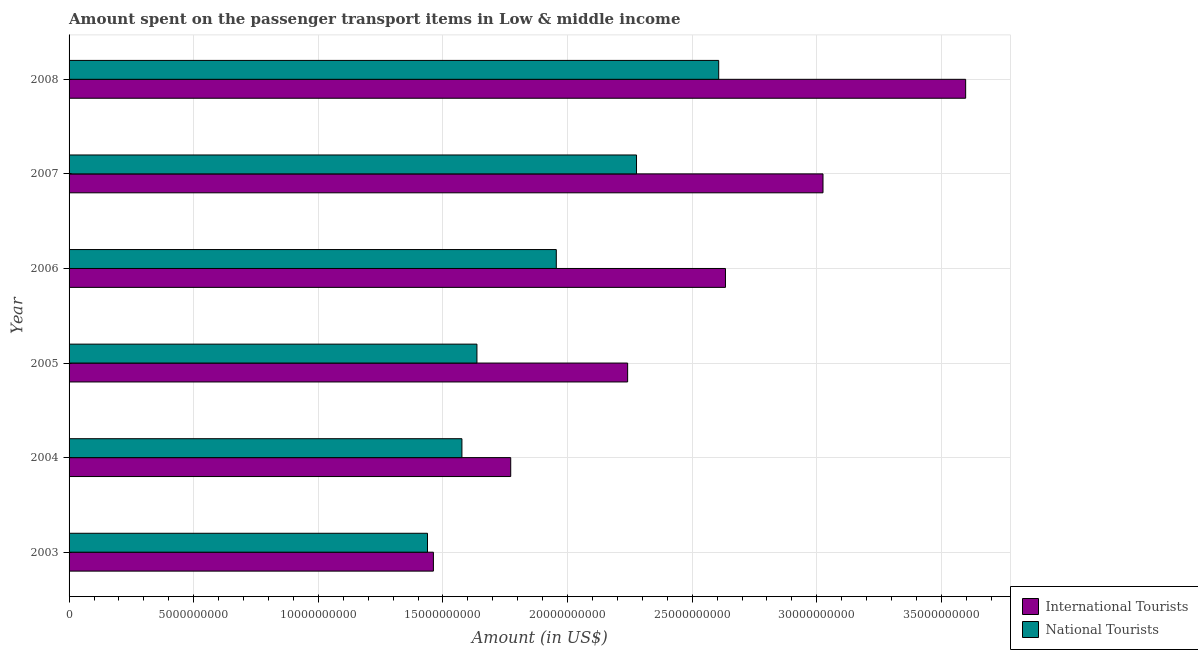How many different coloured bars are there?
Provide a succinct answer. 2. How many groups of bars are there?
Your answer should be compact. 6. Are the number of bars per tick equal to the number of legend labels?
Give a very brief answer. Yes. How many bars are there on the 3rd tick from the top?
Keep it short and to the point. 2. How many bars are there on the 2nd tick from the bottom?
Provide a succinct answer. 2. What is the label of the 5th group of bars from the top?
Offer a terse response. 2004. What is the amount spent on transport items of national tourists in 2008?
Your response must be concise. 2.61e+1. Across all years, what is the maximum amount spent on transport items of national tourists?
Keep it short and to the point. 2.61e+1. Across all years, what is the minimum amount spent on transport items of international tourists?
Offer a very short reply. 1.46e+1. What is the total amount spent on transport items of international tourists in the graph?
Make the answer very short. 1.47e+11. What is the difference between the amount spent on transport items of national tourists in 2005 and that in 2006?
Your answer should be very brief. -3.18e+09. What is the difference between the amount spent on transport items of national tourists in 2005 and the amount spent on transport items of international tourists in 2006?
Ensure brevity in your answer.  -9.97e+09. What is the average amount spent on transport items of international tourists per year?
Give a very brief answer. 2.46e+1. In the year 2004, what is the difference between the amount spent on transport items of international tourists and amount spent on transport items of national tourists?
Your response must be concise. 1.96e+09. What is the ratio of the amount spent on transport items of international tourists in 2004 to that in 2006?
Make the answer very short. 0.67. Is the difference between the amount spent on transport items of national tourists in 2003 and 2005 greater than the difference between the amount spent on transport items of international tourists in 2003 and 2005?
Provide a short and direct response. Yes. What is the difference between the highest and the second highest amount spent on transport items of national tourists?
Offer a terse response. 3.30e+09. What is the difference between the highest and the lowest amount spent on transport items of national tourists?
Your answer should be compact. 1.17e+1. Is the sum of the amount spent on transport items of national tourists in 2005 and 2006 greater than the maximum amount spent on transport items of international tourists across all years?
Offer a terse response. No. What does the 2nd bar from the top in 2008 represents?
Keep it short and to the point. International Tourists. What does the 2nd bar from the bottom in 2008 represents?
Give a very brief answer. National Tourists. How many bars are there?
Make the answer very short. 12. Are all the bars in the graph horizontal?
Keep it short and to the point. Yes. How many years are there in the graph?
Keep it short and to the point. 6. What is the difference between two consecutive major ticks on the X-axis?
Make the answer very short. 5.00e+09. What is the title of the graph?
Your answer should be compact. Amount spent on the passenger transport items in Low & middle income. What is the label or title of the X-axis?
Provide a succinct answer. Amount (in US$). What is the Amount (in US$) of International Tourists in 2003?
Make the answer very short. 1.46e+1. What is the Amount (in US$) of National Tourists in 2003?
Your response must be concise. 1.44e+1. What is the Amount (in US$) of International Tourists in 2004?
Ensure brevity in your answer.  1.77e+1. What is the Amount (in US$) in National Tourists in 2004?
Offer a very short reply. 1.58e+1. What is the Amount (in US$) in International Tourists in 2005?
Provide a short and direct response. 2.24e+1. What is the Amount (in US$) of National Tourists in 2005?
Offer a terse response. 1.64e+1. What is the Amount (in US$) in International Tourists in 2006?
Your response must be concise. 2.63e+1. What is the Amount (in US$) in National Tourists in 2006?
Make the answer very short. 1.95e+1. What is the Amount (in US$) in International Tourists in 2007?
Make the answer very short. 3.02e+1. What is the Amount (in US$) in National Tourists in 2007?
Offer a very short reply. 2.28e+1. What is the Amount (in US$) in International Tourists in 2008?
Give a very brief answer. 3.60e+1. What is the Amount (in US$) of National Tourists in 2008?
Offer a terse response. 2.61e+1. Across all years, what is the maximum Amount (in US$) of International Tourists?
Ensure brevity in your answer.  3.60e+1. Across all years, what is the maximum Amount (in US$) of National Tourists?
Make the answer very short. 2.61e+1. Across all years, what is the minimum Amount (in US$) in International Tourists?
Offer a very short reply. 1.46e+1. Across all years, what is the minimum Amount (in US$) of National Tourists?
Your response must be concise. 1.44e+1. What is the total Amount (in US$) of International Tourists in the graph?
Provide a succinct answer. 1.47e+11. What is the total Amount (in US$) of National Tourists in the graph?
Offer a terse response. 1.15e+11. What is the difference between the Amount (in US$) in International Tourists in 2003 and that in 2004?
Your answer should be compact. -3.10e+09. What is the difference between the Amount (in US$) of National Tourists in 2003 and that in 2004?
Provide a short and direct response. -1.38e+09. What is the difference between the Amount (in US$) in International Tourists in 2003 and that in 2005?
Ensure brevity in your answer.  -7.79e+09. What is the difference between the Amount (in US$) of National Tourists in 2003 and that in 2005?
Offer a terse response. -1.98e+09. What is the difference between the Amount (in US$) in International Tourists in 2003 and that in 2006?
Make the answer very short. -1.17e+1. What is the difference between the Amount (in US$) in National Tourists in 2003 and that in 2006?
Provide a short and direct response. -5.17e+09. What is the difference between the Amount (in US$) in International Tourists in 2003 and that in 2007?
Provide a succinct answer. -1.56e+1. What is the difference between the Amount (in US$) in National Tourists in 2003 and that in 2007?
Make the answer very short. -8.39e+09. What is the difference between the Amount (in US$) in International Tourists in 2003 and that in 2008?
Your answer should be very brief. -2.14e+1. What is the difference between the Amount (in US$) of National Tourists in 2003 and that in 2008?
Ensure brevity in your answer.  -1.17e+1. What is the difference between the Amount (in US$) in International Tourists in 2004 and that in 2005?
Make the answer very short. -4.69e+09. What is the difference between the Amount (in US$) in National Tourists in 2004 and that in 2005?
Your answer should be compact. -6.02e+08. What is the difference between the Amount (in US$) in International Tourists in 2004 and that in 2006?
Your answer should be compact. -8.62e+09. What is the difference between the Amount (in US$) in National Tourists in 2004 and that in 2006?
Offer a terse response. -3.79e+09. What is the difference between the Amount (in US$) in International Tourists in 2004 and that in 2007?
Provide a short and direct response. -1.25e+1. What is the difference between the Amount (in US$) of National Tourists in 2004 and that in 2007?
Make the answer very short. -7.00e+09. What is the difference between the Amount (in US$) of International Tourists in 2004 and that in 2008?
Your answer should be very brief. -1.83e+1. What is the difference between the Amount (in US$) in National Tourists in 2004 and that in 2008?
Your response must be concise. -1.03e+1. What is the difference between the Amount (in US$) of International Tourists in 2005 and that in 2006?
Offer a very short reply. -3.92e+09. What is the difference between the Amount (in US$) of National Tourists in 2005 and that in 2006?
Keep it short and to the point. -3.18e+09. What is the difference between the Amount (in US$) in International Tourists in 2005 and that in 2007?
Give a very brief answer. -7.84e+09. What is the difference between the Amount (in US$) of National Tourists in 2005 and that in 2007?
Make the answer very short. -6.40e+09. What is the difference between the Amount (in US$) in International Tourists in 2005 and that in 2008?
Provide a short and direct response. -1.36e+1. What is the difference between the Amount (in US$) in National Tourists in 2005 and that in 2008?
Provide a short and direct response. -9.70e+09. What is the difference between the Amount (in US$) of International Tourists in 2006 and that in 2007?
Provide a succinct answer. -3.91e+09. What is the difference between the Amount (in US$) of National Tourists in 2006 and that in 2007?
Make the answer very short. -3.22e+09. What is the difference between the Amount (in US$) in International Tourists in 2006 and that in 2008?
Your response must be concise. -9.64e+09. What is the difference between the Amount (in US$) in National Tourists in 2006 and that in 2008?
Make the answer very short. -6.52e+09. What is the difference between the Amount (in US$) in International Tourists in 2007 and that in 2008?
Keep it short and to the point. -5.72e+09. What is the difference between the Amount (in US$) of National Tourists in 2007 and that in 2008?
Your answer should be very brief. -3.30e+09. What is the difference between the Amount (in US$) of International Tourists in 2003 and the Amount (in US$) of National Tourists in 2004?
Offer a terse response. -1.14e+09. What is the difference between the Amount (in US$) of International Tourists in 2003 and the Amount (in US$) of National Tourists in 2005?
Provide a short and direct response. -1.75e+09. What is the difference between the Amount (in US$) of International Tourists in 2003 and the Amount (in US$) of National Tourists in 2006?
Your answer should be compact. -4.93e+09. What is the difference between the Amount (in US$) in International Tourists in 2003 and the Amount (in US$) in National Tourists in 2007?
Make the answer very short. -8.15e+09. What is the difference between the Amount (in US$) of International Tourists in 2003 and the Amount (in US$) of National Tourists in 2008?
Provide a succinct answer. -1.14e+1. What is the difference between the Amount (in US$) in International Tourists in 2004 and the Amount (in US$) in National Tourists in 2005?
Offer a very short reply. 1.36e+09. What is the difference between the Amount (in US$) of International Tourists in 2004 and the Amount (in US$) of National Tourists in 2006?
Provide a short and direct response. -1.83e+09. What is the difference between the Amount (in US$) in International Tourists in 2004 and the Amount (in US$) in National Tourists in 2007?
Provide a succinct answer. -5.05e+09. What is the difference between the Amount (in US$) of International Tourists in 2004 and the Amount (in US$) of National Tourists in 2008?
Offer a very short reply. -8.34e+09. What is the difference between the Amount (in US$) in International Tourists in 2005 and the Amount (in US$) in National Tourists in 2006?
Offer a terse response. 2.86e+09. What is the difference between the Amount (in US$) in International Tourists in 2005 and the Amount (in US$) in National Tourists in 2007?
Keep it short and to the point. -3.56e+08. What is the difference between the Amount (in US$) of International Tourists in 2005 and the Amount (in US$) of National Tourists in 2008?
Provide a short and direct response. -3.65e+09. What is the difference between the Amount (in US$) in International Tourists in 2006 and the Amount (in US$) in National Tourists in 2007?
Keep it short and to the point. 3.57e+09. What is the difference between the Amount (in US$) of International Tourists in 2006 and the Amount (in US$) of National Tourists in 2008?
Ensure brevity in your answer.  2.71e+08. What is the difference between the Amount (in US$) of International Tourists in 2007 and the Amount (in US$) of National Tourists in 2008?
Provide a short and direct response. 4.18e+09. What is the average Amount (in US$) of International Tourists per year?
Provide a short and direct response. 2.46e+1. What is the average Amount (in US$) in National Tourists per year?
Provide a short and direct response. 1.91e+1. In the year 2003, what is the difference between the Amount (in US$) of International Tourists and Amount (in US$) of National Tourists?
Provide a short and direct response. 2.37e+08. In the year 2004, what is the difference between the Amount (in US$) of International Tourists and Amount (in US$) of National Tourists?
Your answer should be very brief. 1.96e+09. In the year 2005, what is the difference between the Amount (in US$) in International Tourists and Amount (in US$) in National Tourists?
Make the answer very short. 6.05e+09. In the year 2006, what is the difference between the Amount (in US$) in International Tourists and Amount (in US$) in National Tourists?
Your answer should be very brief. 6.79e+09. In the year 2007, what is the difference between the Amount (in US$) in International Tourists and Amount (in US$) in National Tourists?
Offer a very short reply. 7.48e+09. In the year 2008, what is the difference between the Amount (in US$) in International Tourists and Amount (in US$) in National Tourists?
Offer a very short reply. 9.91e+09. What is the ratio of the Amount (in US$) of International Tourists in 2003 to that in 2004?
Your response must be concise. 0.82. What is the ratio of the Amount (in US$) of National Tourists in 2003 to that in 2004?
Ensure brevity in your answer.  0.91. What is the ratio of the Amount (in US$) in International Tourists in 2003 to that in 2005?
Your answer should be compact. 0.65. What is the ratio of the Amount (in US$) of National Tourists in 2003 to that in 2005?
Give a very brief answer. 0.88. What is the ratio of the Amount (in US$) of International Tourists in 2003 to that in 2006?
Your answer should be very brief. 0.56. What is the ratio of the Amount (in US$) of National Tourists in 2003 to that in 2006?
Provide a succinct answer. 0.74. What is the ratio of the Amount (in US$) in International Tourists in 2003 to that in 2007?
Ensure brevity in your answer.  0.48. What is the ratio of the Amount (in US$) in National Tourists in 2003 to that in 2007?
Offer a very short reply. 0.63. What is the ratio of the Amount (in US$) of International Tourists in 2003 to that in 2008?
Your answer should be compact. 0.41. What is the ratio of the Amount (in US$) of National Tourists in 2003 to that in 2008?
Give a very brief answer. 0.55. What is the ratio of the Amount (in US$) in International Tourists in 2004 to that in 2005?
Keep it short and to the point. 0.79. What is the ratio of the Amount (in US$) in National Tourists in 2004 to that in 2005?
Your answer should be very brief. 0.96. What is the ratio of the Amount (in US$) of International Tourists in 2004 to that in 2006?
Provide a succinct answer. 0.67. What is the ratio of the Amount (in US$) in National Tourists in 2004 to that in 2006?
Offer a very short reply. 0.81. What is the ratio of the Amount (in US$) in International Tourists in 2004 to that in 2007?
Offer a terse response. 0.59. What is the ratio of the Amount (in US$) of National Tourists in 2004 to that in 2007?
Ensure brevity in your answer.  0.69. What is the ratio of the Amount (in US$) of International Tourists in 2004 to that in 2008?
Offer a very short reply. 0.49. What is the ratio of the Amount (in US$) in National Tourists in 2004 to that in 2008?
Ensure brevity in your answer.  0.6. What is the ratio of the Amount (in US$) of International Tourists in 2005 to that in 2006?
Your answer should be very brief. 0.85. What is the ratio of the Amount (in US$) of National Tourists in 2005 to that in 2006?
Keep it short and to the point. 0.84. What is the ratio of the Amount (in US$) in International Tourists in 2005 to that in 2007?
Offer a terse response. 0.74. What is the ratio of the Amount (in US$) of National Tourists in 2005 to that in 2007?
Your answer should be compact. 0.72. What is the ratio of the Amount (in US$) in International Tourists in 2005 to that in 2008?
Provide a succinct answer. 0.62. What is the ratio of the Amount (in US$) in National Tourists in 2005 to that in 2008?
Provide a succinct answer. 0.63. What is the ratio of the Amount (in US$) in International Tourists in 2006 to that in 2007?
Give a very brief answer. 0.87. What is the ratio of the Amount (in US$) in National Tourists in 2006 to that in 2007?
Your answer should be very brief. 0.86. What is the ratio of the Amount (in US$) in International Tourists in 2006 to that in 2008?
Keep it short and to the point. 0.73. What is the ratio of the Amount (in US$) of National Tourists in 2006 to that in 2008?
Your response must be concise. 0.75. What is the ratio of the Amount (in US$) in International Tourists in 2007 to that in 2008?
Your answer should be very brief. 0.84. What is the ratio of the Amount (in US$) in National Tourists in 2007 to that in 2008?
Make the answer very short. 0.87. What is the difference between the highest and the second highest Amount (in US$) of International Tourists?
Your response must be concise. 5.72e+09. What is the difference between the highest and the second highest Amount (in US$) in National Tourists?
Give a very brief answer. 3.30e+09. What is the difference between the highest and the lowest Amount (in US$) of International Tourists?
Provide a succinct answer. 2.14e+1. What is the difference between the highest and the lowest Amount (in US$) in National Tourists?
Your answer should be very brief. 1.17e+1. 